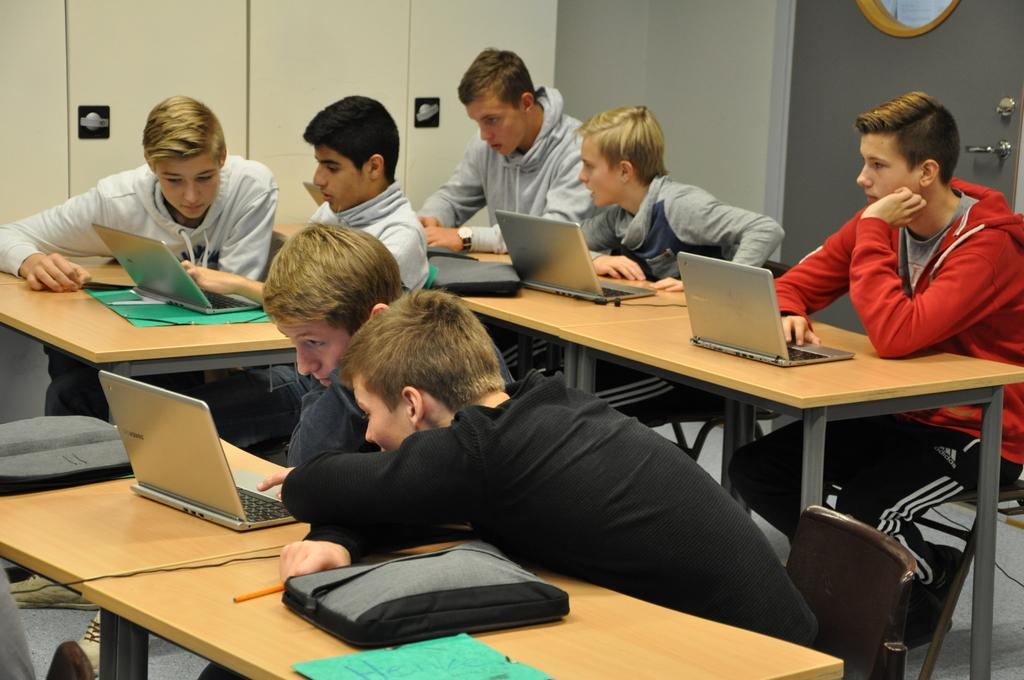What is one of the main objects in the image? There is a door in the image. What are the people in the image doing? The people are sitting on chairs in the image. What piece of furniture is present in the image? There is a table in the image. What electronic devices can be seen on the table? There are laptops on the table in the image. What type of breakfast is being prepared on the stove in the image? There is no stove or breakfast present in the image. What kind of turkey can be seen on the table in the image? There is no turkey present in the image; only laptops are visible on the table. 